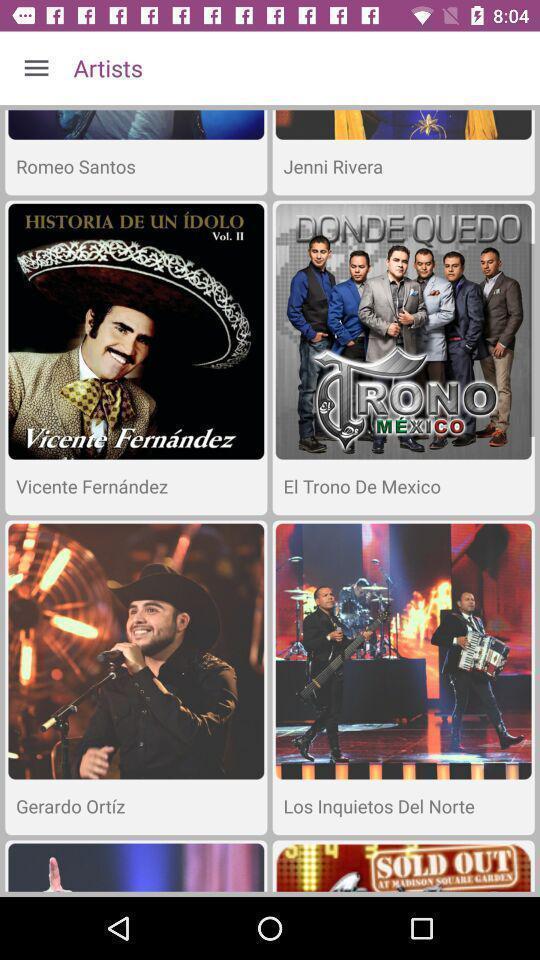What is the overall content of this screenshot? Screen shows various artists present. 